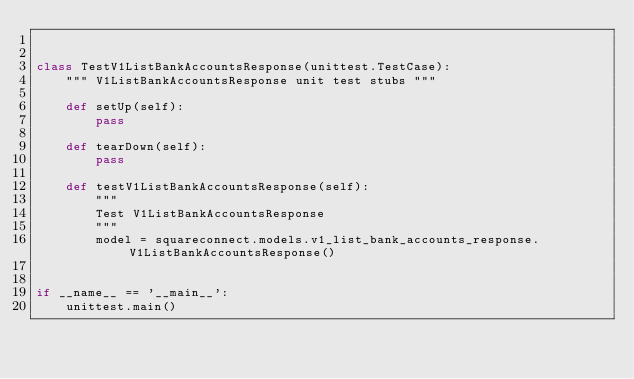<code> <loc_0><loc_0><loc_500><loc_500><_Python_>

class TestV1ListBankAccountsResponse(unittest.TestCase):
    """ V1ListBankAccountsResponse unit test stubs """

    def setUp(self):
        pass

    def tearDown(self):
        pass

    def testV1ListBankAccountsResponse(self):
        """
        Test V1ListBankAccountsResponse
        """
        model = squareconnect.models.v1_list_bank_accounts_response.V1ListBankAccountsResponse()


if __name__ == '__main__':
    unittest.main()
</code> 